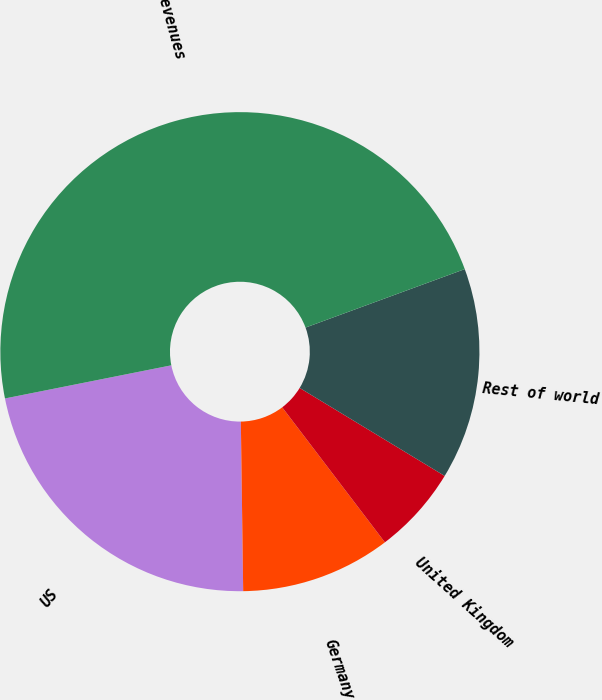Convert chart to OTSL. <chart><loc_0><loc_0><loc_500><loc_500><pie_chart><fcel>US<fcel>Germany<fcel>United Kingdom<fcel>Rest of world<fcel>Total net revenues<nl><fcel>22.09%<fcel>10.13%<fcel>5.97%<fcel>14.28%<fcel>47.53%<nl></chart> 